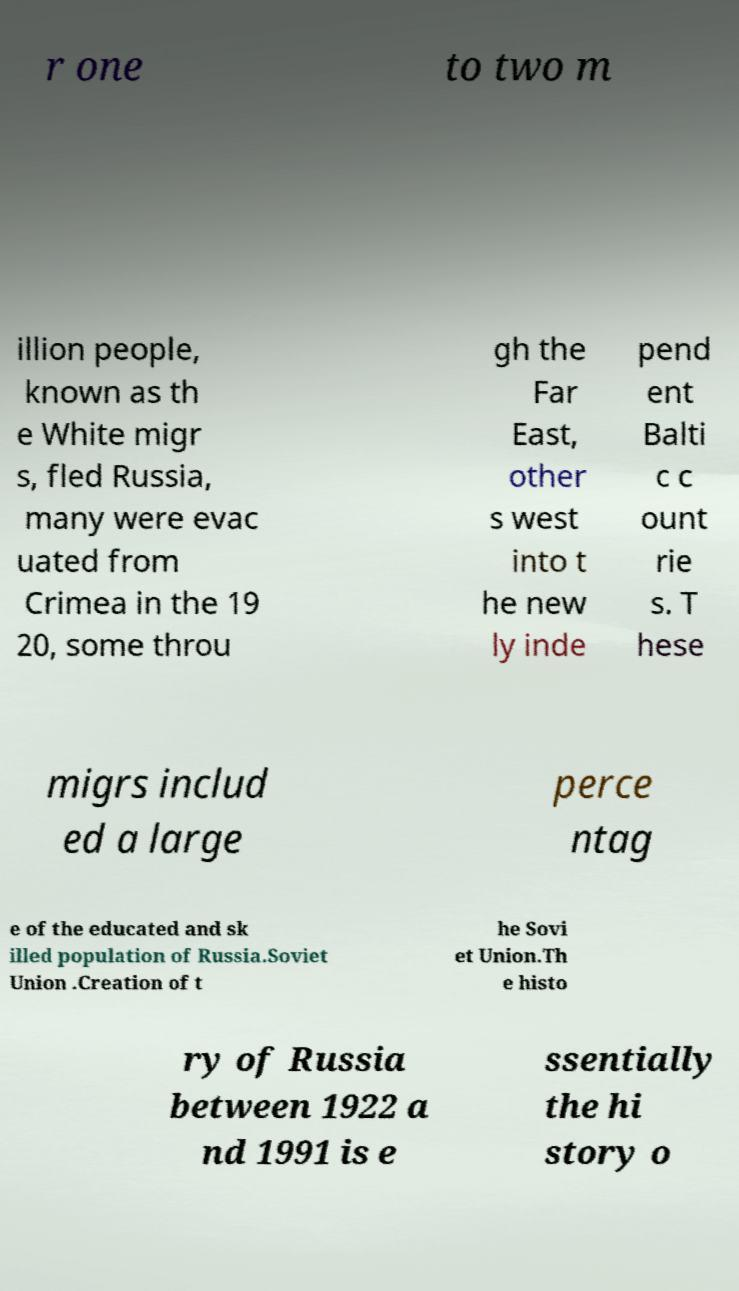I need the written content from this picture converted into text. Can you do that? r one to two m illion people, known as th e White migr s, fled Russia, many were evac uated from Crimea in the 19 20, some throu gh the Far East, other s west into t he new ly inde pend ent Balti c c ount rie s. T hese migrs includ ed a large perce ntag e of the educated and sk illed population of Russia.Soviet Union .Creation of t he Sovi et Union.Th e histo ry of Russia between 1922 a nd 1991 is e ssentially the hi story o 